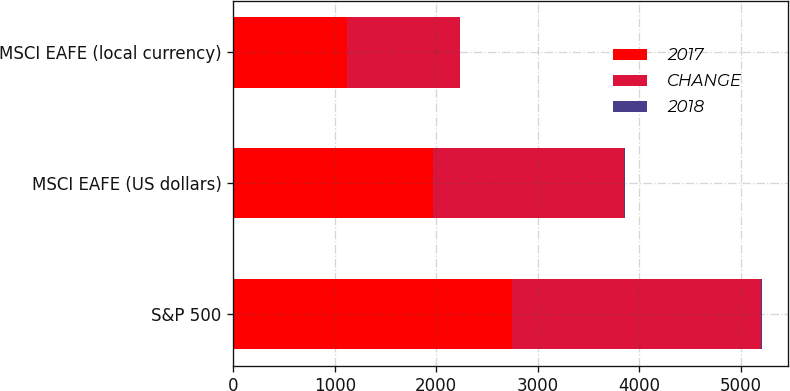Convert chart to OTSL. <chart><loc_0><loc_0><loc_500><loc_500><stacked_bar_chart><ecel><fcel>S&P 500<fcel>MSCI EAFE (US dollars)<fcel>MSCI EAFE (local currency)<nl><fcel>2017<fcel>2746<fcel>1966<fcel>1125<nl><fcel>CHANGE<fcel>2448<fcel>1886<fcel>1105<nl><fcel>2018<fcel>12<fcel>4<fcel>2<nl></chart> 